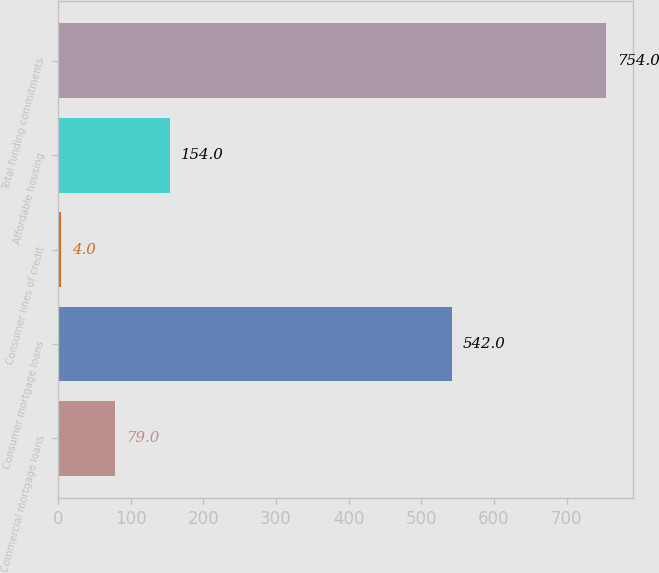Convert chart. <chart><loc_0><loc_0><loc_500><loc_500><bar_chart><fcel>Commercial mortgage loans<fcel>Consumer mortgage loans<fcel>Consumer lines of credit<fcel>Affordable housing<fcel>Total funding commitments<nl><fcel>79<fcel>542<fcel>4<fcel>154<fcel>754<nl></chart> 